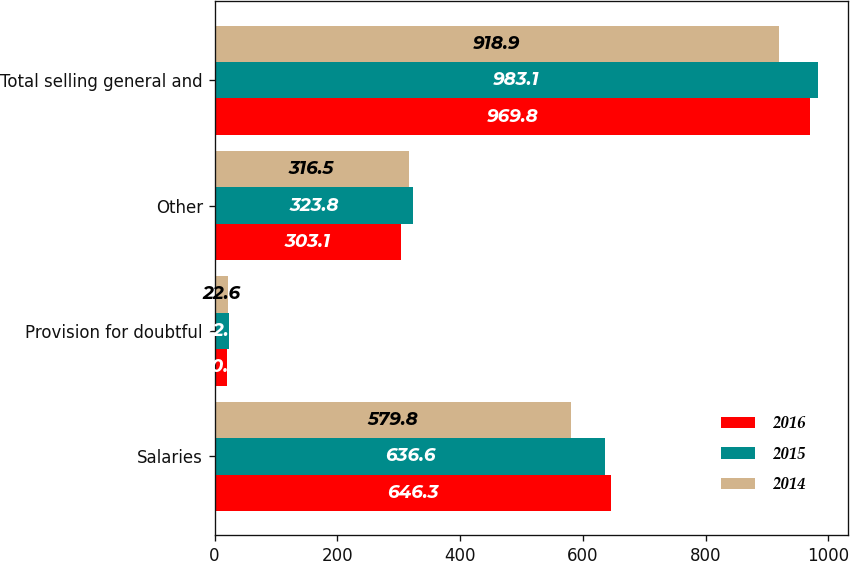<chart> <loc_0><loc_0><loc_500><loc_500><stacked_bar_chart><ecel><fcel>Salaries<fcel>Provision for doubtful<fcel>Other<fcel>Total selling general and<nl><fcel>2016<fcel>646.3<fcel>20.4<fcel>303.1<fcel>969.8<nl><fcel>2015<fcel>636.6<fcel>22.7<fcel>323.8<fcel>983.1<nl><fcel>2014<fcel>579.8<fcel>22.6<fcel>316.5<fcel>918.9<nl></chart> 